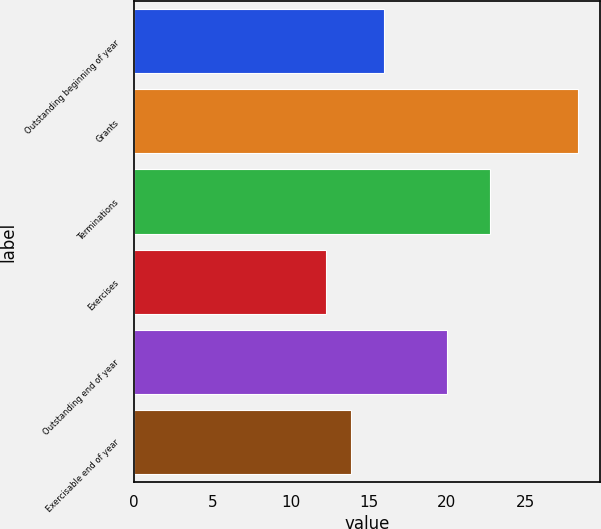<chart> <loc_0><loc_0><loc_500><loc_500><bar_chart><fcel>Outstanding beginning of year<fcel>Grants<fcel>Terminations<fcel>Exercises<fcel>Outstanding end of year<fcel>Exercisable end of year<nl><fcel>15.98<fcel>28.36<fcel>22.74<fcel>12.27<fcel>20.01<fcel>13.88<nl></chart> 